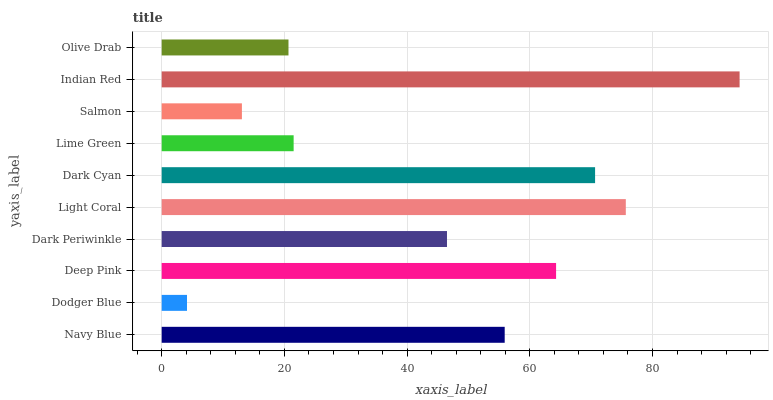Is Dodger Blue the minimum?
Answer yes or no. Yes. Is Indian Red the maximum?
Answer yes or no. Yes. Is Deep Pink the minimum?
Answer yes or no. No. Is Deep Pink the maximum?
Answer yes or no. No. Is Deep Pink greater than Dodger Blue?
Answer yes or no. Yes. Is Dodger Blue less than Deep Pink?
Answer yes or no. Yes. Is Dodger Blue greater than Deep Pink?
Answer yes or no. No. Is Deep Pink less than Dodger Blue?
Answer yes or no. No. Is Navy Blue the high median?
Answer yes or no. Yes. Is Dark Periwinkle the low median?
Answer yes or no. Yes. Is Dark Cyan the high median?
Answer yes or no. No. Is Indian Red the low median?
Answer yes or no. No. 